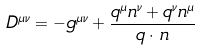<formula> <loc_0><loc_0><loc_500><loc_500>D ^ { \mu \nu } = - g ^ { \mu \nu } + \frac { q ^ { \mu } n ^ { \nu } + q ^ { \nu } n ^ { \mu } } { q \cdot \, n }</formula> 